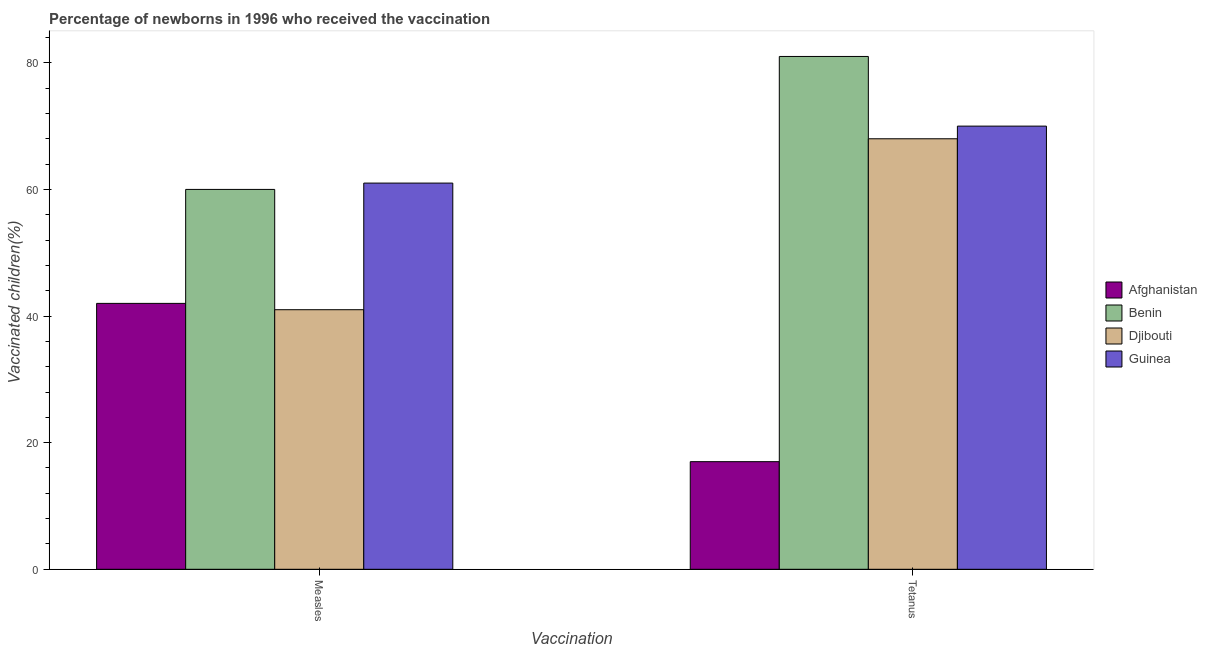Are the number of bars per tick equal to the number of legend labels?
Provide a succinct answer. Yes. How many bars are there on the 1st tick from the left?
Make the answer very short. 4. What is the label of the 2nd group of bars from the left?
Offer a terse response. Tetanus. What is the percentage of newborns who received vaccination for tetanus in Benin?
Offer a very short reply. 81. Across all countries, what is the maximum percentage of newborns who received vaccination for tetanus?
Provide a short and direct response. 81. Across all countries, what is the minimum percentage of newborns who received vaccination for measles?
Provide a short and direct response. 41. In which country was the percentage of newborns who received vaccination for tetanus maximum?
Your response must be concise. Benin. In which country was the percentage of newborns who received vaccination for measles minimum?
Offer a terse response. Djibouti. What is the total percentage of newborns who received vaccination for tetanus in the graph?
Your answer should be very brief. 236. What is the difference between the percentage of newborns who received vaccination for tetanus in Guinea and that in Benin?
Your answer should be very brief. -11. What is the difference between the percentage of newborns who received vaccination for measles in Djibouti and the percentage of newborns who received vaccination for tetanus in Afghanistan?
Your response must be concise. 24. What is the difference between the percentage of newborns who received vaccination for measles and percentage of newborns who received vaccination for tetanus in Guinea?
Keep it short and to the point. -9. In how many countries, is the percentage of newborns who received vaccination for tetanus greater than 76 %?
Provide a succinct answer. 1. What is the ratio of the percentage of newborns who received vaccination for measles in Guinea to that in Djibouti?
Ensure brevity in your answer.  1.49. In how many countries, is the percentage of newborns who received vaccination for measles greater than the average percentage of newborns who received vaccination for measles taken over all countries?
Ensure brevity in your answer.  2. What does the 4th bar from the left in Measles represents?
Your response must be concise. Guinea. What does the 1st bar from the right in Tetanus represents?
Offer a very short reply. Guinea. How many bars are there?
Your response must be concise. 8. How many countries are there in the graph?
Ensure brevity in your answer.  4. Does the graph contain any zero values?
Your answer should be compact. No. Does the graph contain grids?
Provide a short and direct response. No. How many legend labels are there?
Keep it short and to the point. 4. How are the legend labels stacked?
Your response must be concise. Vertical. What is the title of the graph?
Keep it short and to the point. Percentage of newborns in 1996 who received the vaccination. What is the label or title of the X-axis?
Offer a terse response. Vaccination. What is the label or title of the Y-axis?
Give a very brief answer. Vaccinated children(%)
. What is the Vaccinated children(%)
 in Afghanistan in Measles?
Your answer should be very brief. 42. What is the Vaccinated children(%)
 in Djibouti in Measles?
Provide a succinct answer. 41. What is the Vaccinated children(%)
 in Guinea in Measles?
Offer a terse response. 61. Across all Vaccination, what is the maximum Vaccinated children(%)
 in Afghanistan?
Ensure brevity in your answer.  42. Across all Vaccination, what is the maximum Vaccinated children(%)
 in Djibouti?
Your answer should be compact. 68. Across all Vaccination, what is the minimum Vaccinated children(%)
 in Afghanistan?
Offer a very short reply. 17. Across all Vaccination, what is the minimum Vaccinated children(%)
 in Guinea?
Ensure brevity in your answer.  61. What is the total Vaccinated children(%)
 of Afghanistan in the graph?
Provide a succinct answer. 59. What is the total Vaccinated children(%)
 of Benin in the graph?
Offer a terse response. 141. What is the total Vaccinated children(%)
 of Djibouti in the graph?
Your response must be concise. 109. What is the total Vaccinated children(%)
 in Guinea in the graph?
Your response must be concise. 131. What is the difference between the Vaccinated children(%)
 in Afghanistan in Measles and that in Tetanus?
Ensure brevity in your answer.  25. What is the difference between the Vaccinated children(%)
 of Benin in Measles and that in Tetanus?
Your answer should be very brief. -21. What is the difference between the Vaccinated children(%)
 in Djibouti in Measles and that in Tetanus?
Offer a terse response. -27. What is the difference between the Vaccinated children(%)
 of Afghanistan in Measles and the Vaccinated children(%)
 of Benin in Tetanus?
Keep it short and to the point. -39. What is the difference between the Vaccinated children(%)
 of Afghanistan in Measles and the Vaccinated children(%)
 of Guinea in Tetanus?
Offer a very short reply. -28. What is the difference between the Vaccinated children(%)
 of Djibouti in Measles and the Vaccinated children(%)
 of Guinea in Tetanus?
Offer a terse response. -29. What is the average Vaccinated children(%)
 in Afghanistan per Vaccination?
Give a very brief answer. 29.5. What is the average Vaccinated children(%)
 of Benin per Vaccination?
Provide a short and direct response. 70.5. What is the average Vaccinated children(%)
 of Djibouti per Vaccination?
Provide a short and direct response. 54.5. What is the average Vaccinated children(%)
 in Guinea per Vaccination?
Provide a succinct answer. 65.5. What is the difference between the Vaccinated children(%)
 of Afghanistan and Vaccinated children(%)
 of Djibouti in Measles?
Ensure brevity in your answer.  1. What is the difference between the Vaccinated children(%)
 in Afghanistan and Vaccinated children(%)
 in Guinea in Measles?
Your answer should be very brief. -19. What is the difference between the Vaccinated children(%)
 in Benin and Vaccinated children(%)
 in Guinea in Measles?
Your answer should be very brief. -1. What is the difference between the Vaccinated children(%)
 of Afghanistan and Vaccinated children(%)
 of Benin in Tetanus?
Make the answer very short. -64. What is the difference between the Vaccinated children(%)
 in Afghanistan and Vaccinated children(%)
 in Djibouti in Tetanus?
Offer a very short reply. -51. What is the difference between the Vaccinated children(%)
 in Afghanistan and Vaccinated children(%)
 in Guinea in Tetanus?
Provide a short and direct response. -53. What is the difference between the Vaccinated children(%)
 of Benin and Vaccinated children(%)
 of Djibouti in Tetanus?
Offer a very short reply. 13. What is the difference between the Vaccinated children(%)
 of Benin and Vaccinated children(%)
 of Guinea in Tetanus?
Your answer should be compact. 11. What is the difference between the Vaccinated children(%)
 in Djibouti and Vaccinated children(%)
 in Guinea in Tetanus?
Make the answer very short. -2. What is the ratio of the Vaccinated children(%)
 of Afghanistan in Measles to that in Tetanus?
Offer a terse response. 2.47. What is the ratio of the Vaccinated children(%)
 in Benin in Measles to that in Tetanus?
Make the answer very short. 0.74. What is the ratio of the Vaccinated children(%)
 of Djibouti in Measles to that in Tetanus?
Ensure brevity in your answer.  0.6. What is the ratio of the Vaccinated children(%)
 in Guinea in Measles to that in Tetanus?
Give a very brief answer. 0.87. What is the difference between the highest and the second highest Vaccinated children(%)
 of Benin?
Provide a succinct answer. 21. What is the difference between the highest and the second highest Vaccinated children(%)
 in Guinea?
Provide a succinct answer. 9. What is the difference between the highest and the lowest Vaccinated children(%)
 in Djibouti?
Offer a very short reply. 27. What is the difference between the highest and the lowest Vaccinated children(%)
 of Guinea?
Your response must be concise. 9. 